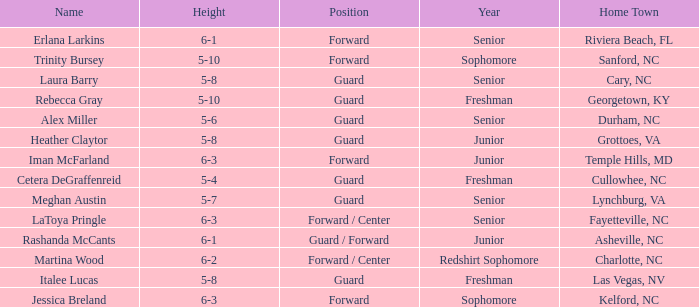What is the name of the guard from Cary, NC? Laura Barry. 